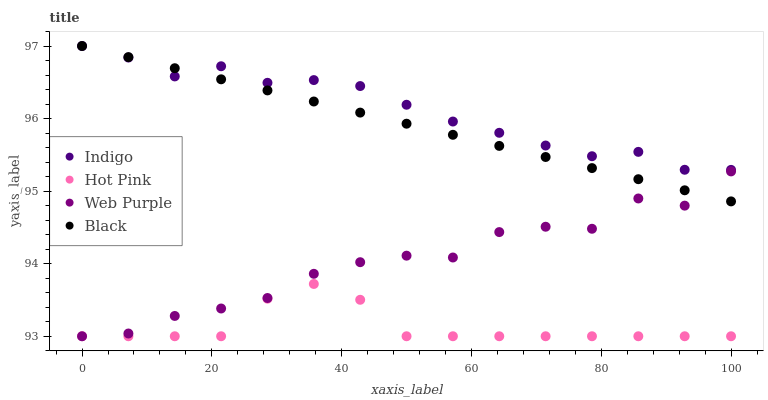Does Hot Pink have the minimum area under the curve?
Answer yes or no. Yes. Does Indigo have the maximum area under the curve?
Answer yes or no. Yes. Does Web Purple have the minimum area under the curve?
Answer yes or no. No. Does Web Purple have the maximum area under the curve?
Answer yes or no. No. Is Black the smoothest?
Answer yes or no. Yes. Is Web Purple the roughest?
Answer yes or no. Yes. Is Hot Pink the smoothest?
Answer yes or no. No. Is Hot Pink the roughest?
Answer yes or no. No. Does Web Purple have the lowest value?
Answer yes or no. Yes. Does Indigo have the lowest value?
Answer yes or no. No. Does Indigo have the highest value?
Answer yes or no. Yes. Does Web Purple have the highest value?
Answer yes or no. No. Is Hot Pink less than Indigo?
Answer yes or no. Yes. Is Indigo greater than Hot Pink?
Answer yes or no. Yes. Does Web Purple intersect Hot Pink?
Answer yes or no. Yes. Is Web Purple less than Hot Pink?
Answer yes or no. No. Is Web Purple greater than Hot Pink?
Answer yes or no. No. Does Hot Pink intersect Indigo?
Answer yes or no. No. 